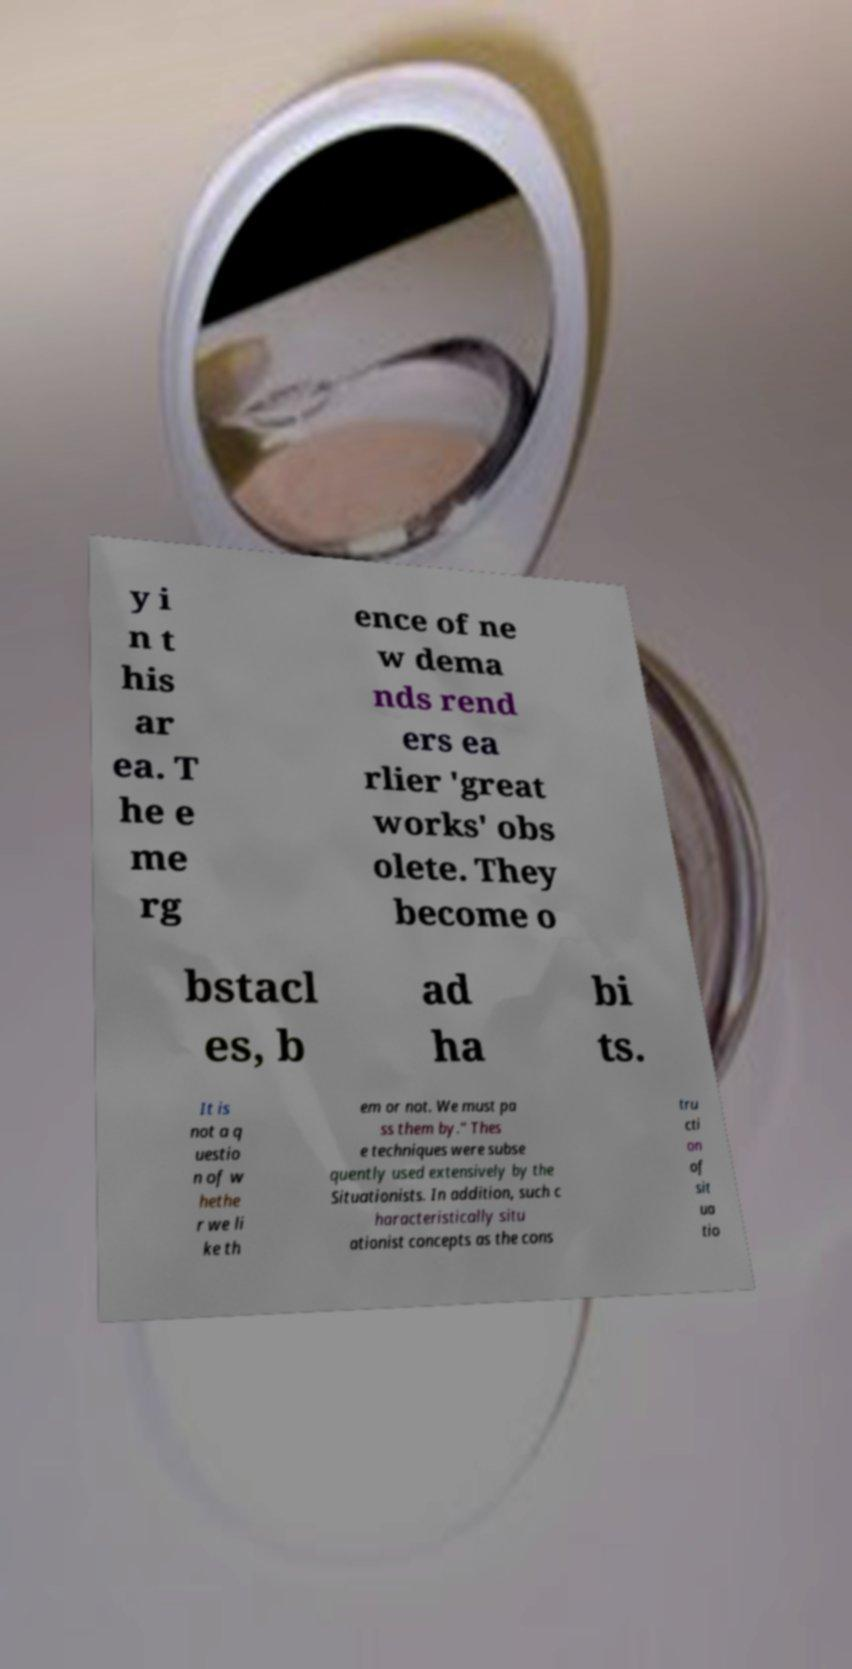What messages or text are displayed in this image? I need them in a readable, typed format. y i n t his ar ea. T he e me rg ence of ne w dema nds rend ers ea rlier 'great works' obs olete. They become o bstacl es, b ad ha bi ts. It is not a q uestio n of w hethe r we li ke th em or not. We must pa ss them by." Thes e techniques were subse quently used extensively by the Situationists. In addition, such c haracteristically situ ationist concepts as the cons tru cti on of sit ua tio 